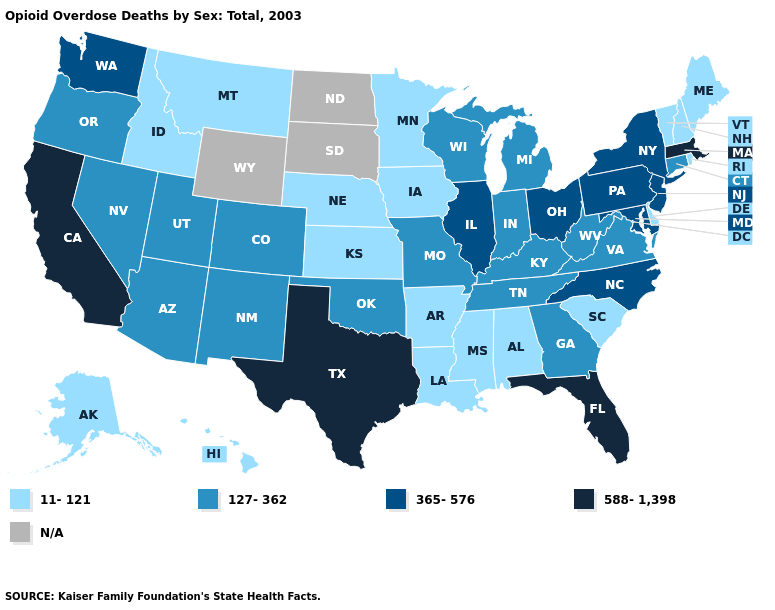Does Ohio have the highest value in the MidWest?
Answer briefly. Yes. What is the value of Vermont?
Answer briefly. 11-121. Does Texas have the highest value in the South?
Write a very short answer. Yes. What is the highest value in the Northeast ?
Give a very brief answer. 588-1,398. What is the lowest value in the USA?
Keep it brief. 11-121. What is the value of Wisconsin?
Short answer required. 127-362. What is the value of Vermont?
Write a very short answer. 11-121. What is the value of South Carolina?
Write a very short answer. 11-121. Among the states that border Michigan , which have the highest value?
Keep it brief. Ohio. What is the lowest value in states that border Connecticut?
Give a very brief answer. 11-121. What is the highest value in the West ?
Keep it brief. 588-1,398. Name the states that have a value in the range 365-576?
Quick response, please. Illinois, Maryland, New Jersey, New York, North Carolina, Ohio, Pennsylvania, Washington. What is the highest value in the West ?
Quick response, please. 588-1,398. What is the value of Connecticut?
Concise answer only. 127-362. What is the value of Texas?
Write a very short answer. 588-1,398. 